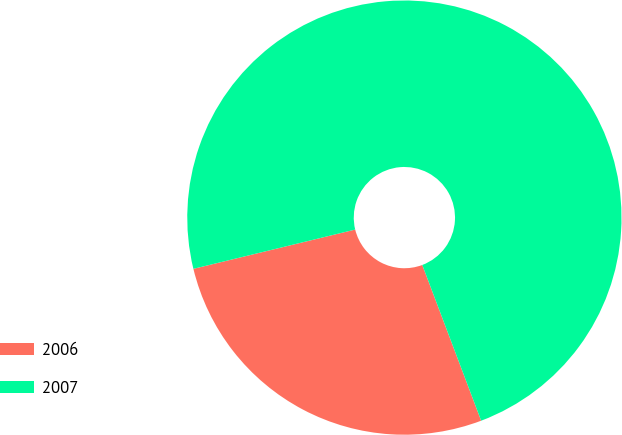Convert chart. <chart><loc_0><loc_0><loc_500><loc_500><pie_chart><fcel>2006<fcel>2007<nl><fcel>26.96%<fcel>73.04%<nl></chart> 